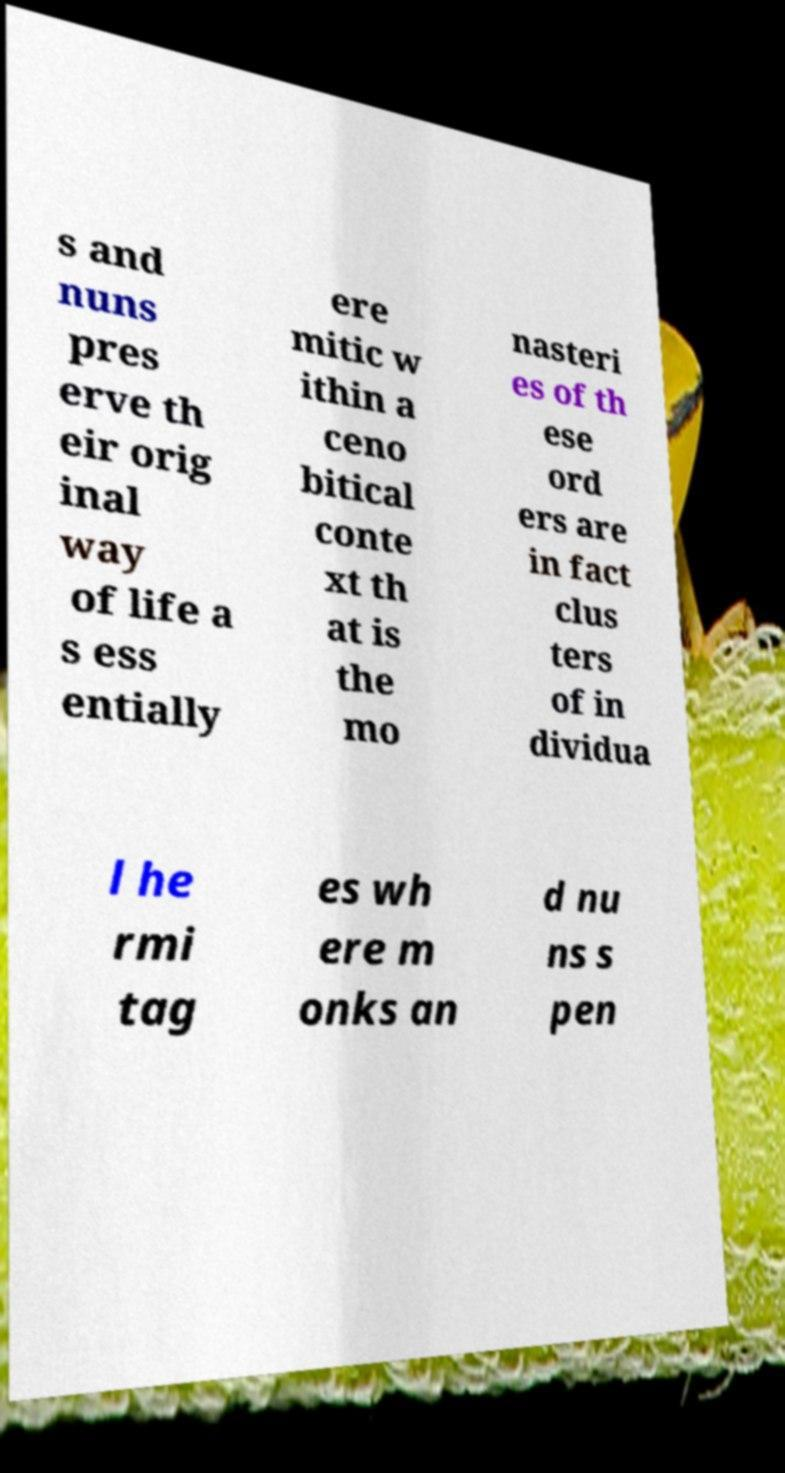Can you accurately transcribe the text from the provided image for me? s and nuns pres erve th eir orig inal way of life a s ess entially ere mitic w ithin a ceno bitical conte xt th at is the mo nasteri es of th ese ord ers are in fact clus ters of in dividua l he rmi tag es wh ere m onks an d nu ns s pen 